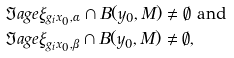<formula> <loc_0><loc_0><loc_500><loc_500>& \Im a g e \xi _ { g _ { i } x _ { 0 } , \alpha } \cap B ( y _ { 0 } , M ) \neq \emptyset \ \text {and} \ \\ & \Im a g e \xi _ { g _ { i } x _ { 0 } , \beta } \cap B ( y _ { 0 } , M ) \neq \emptyset ,</formula> 